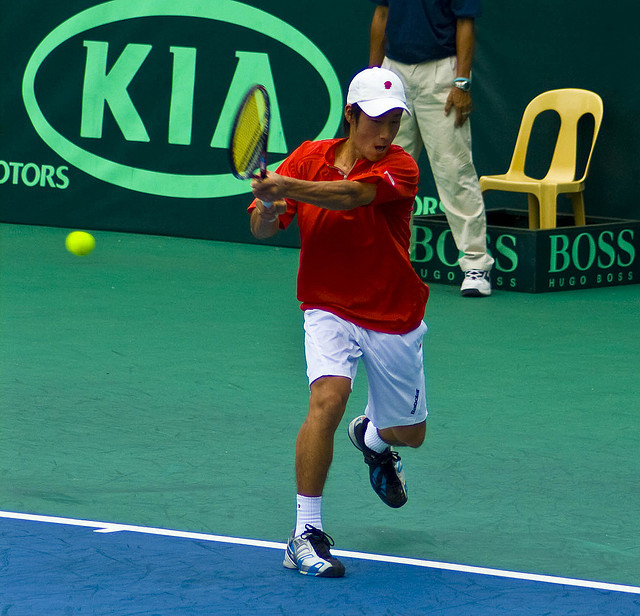Read all the text in this image. K I A BOSS HUGO BOSS BOSS S S UGO R TORS 